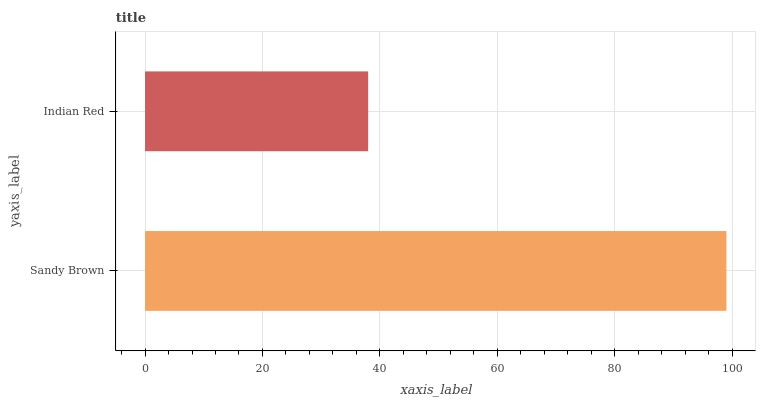Is Indian Red the minimum?
Answer yes or no. Yes. Is Sandy Brown the maximum?
Answer yes or no. Yes. Is Indian Red the maximum?
Answer yes or no. No. Is Sandy Brown greater than Indian Red?
Answer yes or no. Yes. Is Indian Red less than Sandy Brown?
Answer yes or no. Yes. Is Indian Red greater than Sandy Brown?
Answer yes or no. No. Is Sandy Brown less than Indian Red?
Answer yes or no. No. Is Sandy Brown the high median?
Answer yes or no. Yes. Is Indian Red the low median?
Answer yes or no. Yes. Is Indian Red the high median?
Answer yes or no. No. Is Sandy Brown the low median?
Answer yes or no. No. 